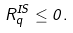Convert formula to latex. <formula><loc_0><loc_0><loc_500><loc_500>R _ { q } ^ { I S } \leq 0 .</formula> 